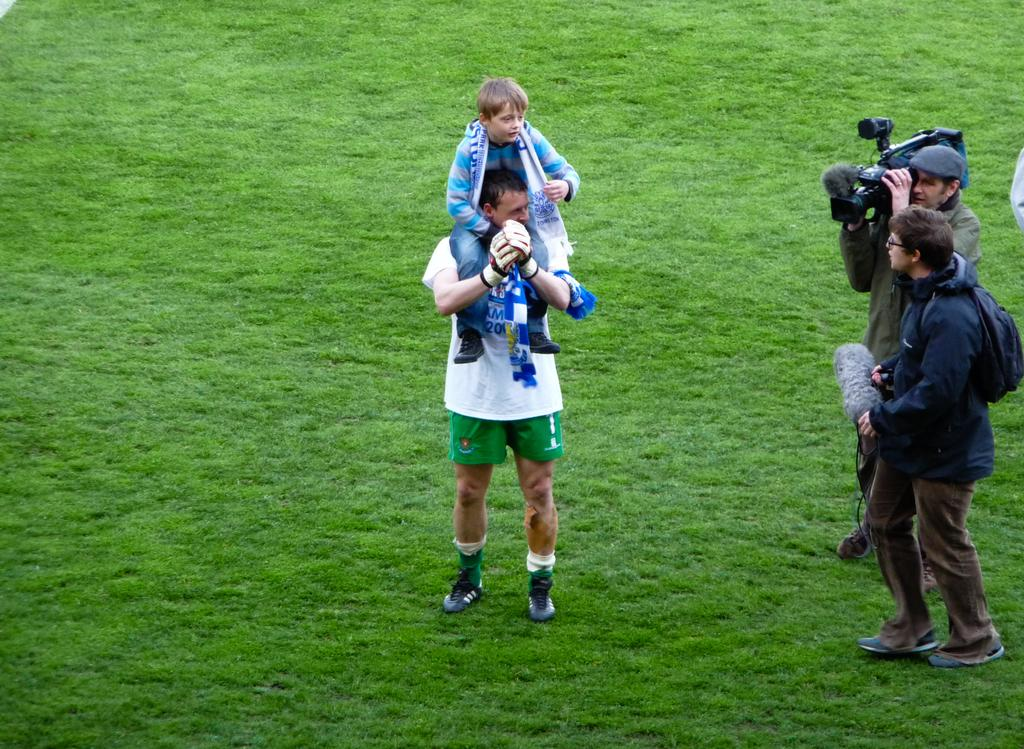How many people are in the image? There are people in the image, but the exact number is not specified. What is one person doing in the image? One person is holding a camera. What is another person holding in the image? Another person is holding an object. What type of natural environment is visible in the image? There is grass visible in the image. What type of rock can be seen in the image? There is no rock present in the image; it features people, a camera, an object, and grass. How does the image demonstrate the principles of acoustics? The image does not demonstrate any principles of acoustics, as it focuses on people, a camera, an object, and grass. 